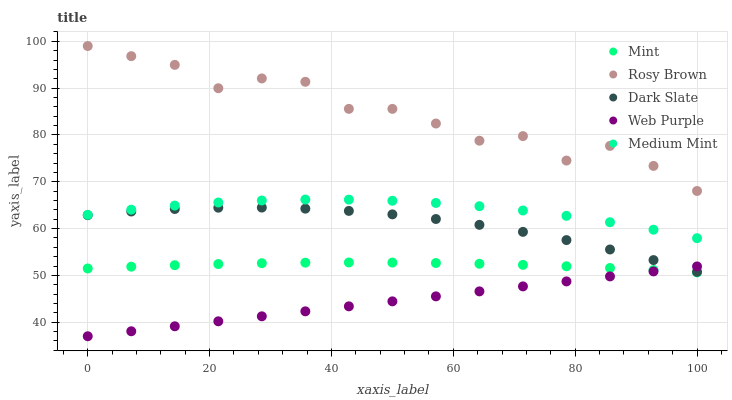Does Web Purple have the minimum area under the curve?
Answer yes or no. Yes. Does Rosy Brown have the maximum area under the curve?
Answer yes or no. Yes. Does Dark Slate have the minimum area under the curve?
Answer yes or no. No. Does Dark Slate have the maximum area under the curve?
Answer yes or no. No. Is Web Purple the smoothest?
Answer yes or no. Yes. Is Rosy Brown the roughest?
Answer yes or no. Yes. Is Dark Slate the smoothest?
Answer yes or no. No. Is Dark Slate the roughest?
Answer yes or no. No. Does Web Purple have the lowest value?
Answer yes or no. Yes. Does Dark Slate have the lowest value?
Answer yes or no. No. Does Rosy Brown have the highest value?
Answer yes or no. Yes. Does Dark Slate have the highest value?
Answer yes or no. No. Is Mint less than Dark Slate?
Answer yes or no. Yes. Is Medium Mint greater than Dark Slate?
Answer yes or no. Yes. Does Web Purple intersect Dark Slate?
Answer yes or no. Yes. Is Web Purple less than Dark Slate?
Answer yes or no. No. Is Web Purple greater than Dark Slate?
Answer yes or no. No. Does Mint intersect Dark Slate?
Answer yes or no. No. 